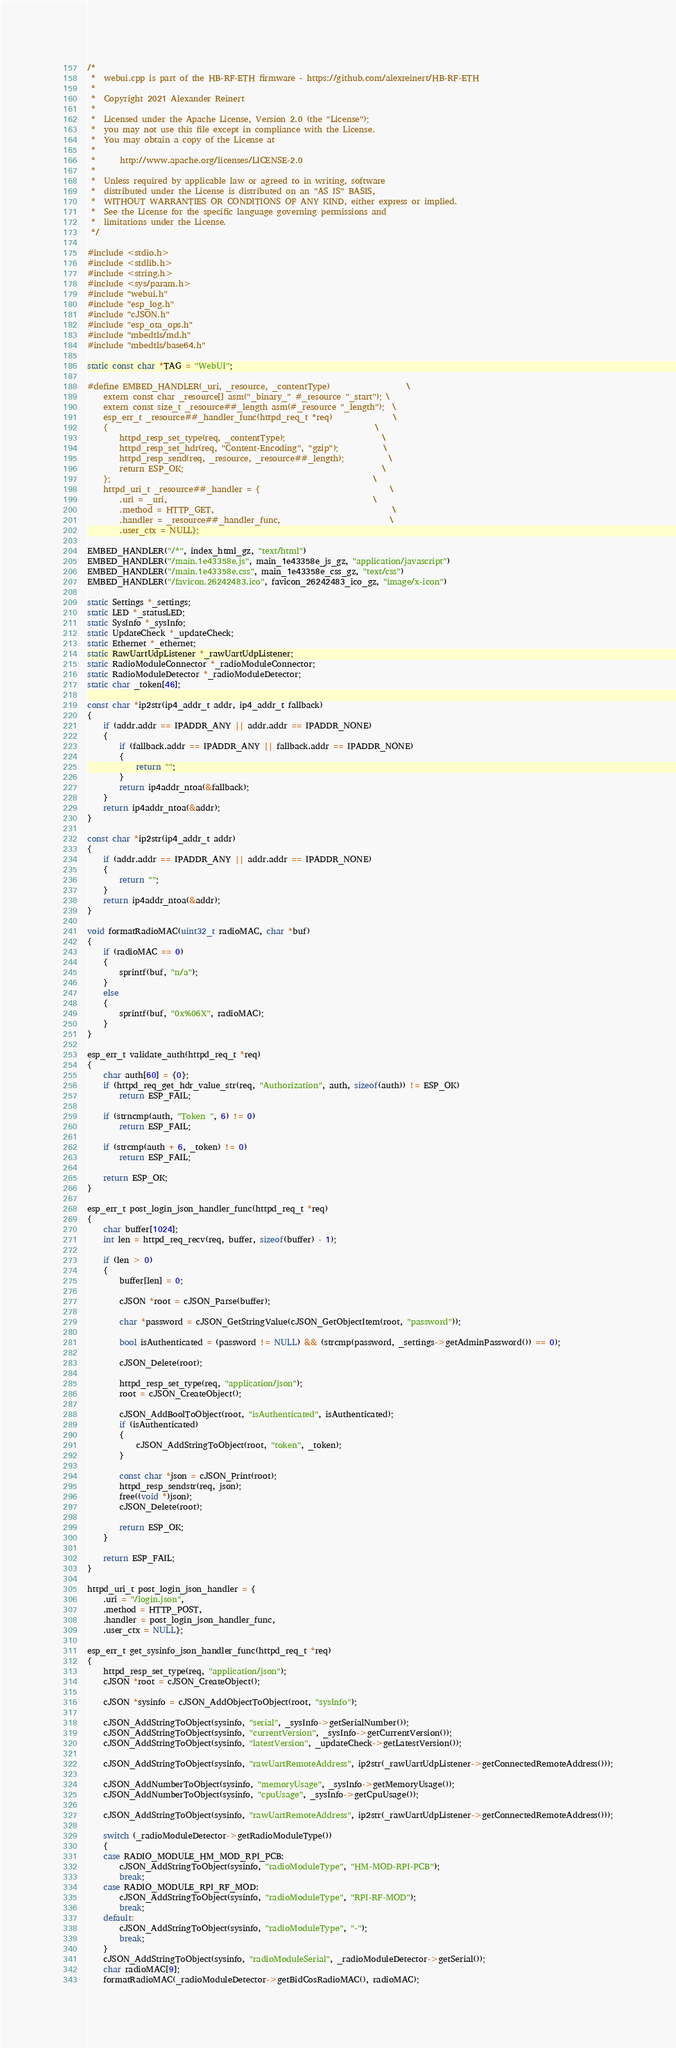Convert code to text. <code><loc_0><loc_0><loc_500><loc_500><_C++_>/* 
 *  webui.cpp is part of the HB-RF-ETH firmware - https://github.com/alexreinert/HB-RF-ETH
 *  
 *  Copyright 2021 Alexander Reinert
 *  
 *  Licensed under the Apache License, Version 2.0 (the "License");
 *  you may not use this file except in compliance with the License.
 *  You may obtain a copy of the License at
 *  
 *      http://www.apache.org/licenses/LICENSE-2.0
 *  
 *  Unless required by applicable law or agreed to in writing, software
 *  distributed under the License is distributed on an "AS IS" BASIS,
 *  WITHOUT WARRANTIES OR CONDITIONS OF ANY KIND, either express or implied.
 *  See the License for the specific language governing permissions and
 *  limitations under the License.
 */

#include <stdio.h>
#include <stdlib.h>
#include <string.h>
#include <sys/param.h>
#include "webui.h"
#include "esp_log.h"
#include "cJSON.h"
#include "esp_ota_ops.h"
#include "mbedtls/md.h"
#include "mbedtls/base64.h"

static const char *TAG = "WebUI";

#define EMBED_HANDLER(_uri, _resource, _contentType)                   \
    extern const char _resource[] asm("_binary_" #_resource "_start"); \
    extern const size_t _resource##_length asm(#_resource "_length");  \
    esp_err_t _resource##_handler_func(httpd_req_t *req)               \
    {                                                                  \
        httpd_resp_set_type(req, _contentType);                        \
        httpd_resp_set_hdr(req, "Content-Encoding", "gzip");           \
        httpd_resp_send(req, _resource, _resource##_length);           \
        return ESP_OK;                                                 \
    };                                                                 \
    httpd_uri_t _resource##_handler = {                                \
        .uri = _uri,                                                   \
        .method = HTTP_GET,                                            \
        .handler = _resource##_handler_func,                           \
        .user_ctx = NULL};

EMBED_HANDLER("/*", index_html_gz, "text/html")
EMBED_HANDLER("/main.1e43358e.js", main_1e43358e_js_gz, "application/javascript")
EMBED_HANDLER("/main.1e43358e.css", main_1e43358e_css_gz, "text/css")
EMBED_HANDLER("/favicon.26242483.ico", favicon_26242483_ico_gz, "image/x-icon")

static Settings *_settings;
static LED *_statusLED;
static SysInfo *_sysInfo;
static UpdateCheck *_updateCheck;
static Ethernet *_ethernet;
static RawUartUdpListener *_rawUartUdpListener;
static RadioModuleConnector *_radioModuleConnector;
static RadioModuleDetector *_radioModuleDetector;
static char _token[46];

const char *ip2str(ip4_addr_t addr, ip4_addr_t fallback)
{
    if (addr.addr == IPADDR_ANY || addr.addr == IPADDR_NONE)
    {
        if (fallback.addr == IPADDR_ANY || fallback.addr == IPADDR_NONE)
        {
            return "";
        }
        return ip4addr_ntoa(&fallback);
    }
    return ip4addr_ntoa(&addr);
}

const char *ip2str(ip4_addr_t addr)
{
    if (addr.addr == IPADDR_ANY || addr.addr == IPADDR_NONE)
    {
        return "";
    }
    return ip4addr_ntoa(&addr);
}

void formatRadioMAC(uint32_t radioMAC, char *buf)
{
    if (radioMAC == 0)
    {
        sprintf(buf, "n/a");
    }
    else
    {
        sprintf(buf, "0x%06X", radioMAC);
    }
}

esp_err_t validate_auth(httpd_req_t *req)
{
    char auth[60] = {0};
    if (httpd_req_get_hdr_value_str(req, "Authorization", auth, sizeof(auth)) != ESP_OK)
        return ESP_FAIL;

    if (strncmp(auth, "Token ", 6) != 0)
        return ESP_FAIL;

    if (strcmp(auth + 6, _token) != 0)
        return ESP_FAIL;

    return ESP_OK;
}

esp_err_t post_login_json_handler_func(httpd_req_t *req)
{
    char buffer[1024];
    int len = httpd_req_recv(req, buffer, sizeof(buffer) - 1);

    if (len > 0)
    {
        buffer[len] = 0;

        cJSON *root = cJSON_Parse(buffer);

        char *password = cJSON_GetStringValue(cJSON_GetObjectItem(root, "password"));

        bool isAuthenticated = (password != NULL) && (strcmp(password, _settings->getAdminPassword()) == 0);

        cJSON_Delete(root);

        httpd_resp_set_type(req, "application/json");
        root = cJSON_CreateObject();

        cJSON_AddBoolToObject(root, "isAuthenticated", isAuthenticated);
        if (isAuthenticated)
        {
            cJSON_AddStringToObject(root, "token", _token);
        }

        const char *json = cJSON_Print(root);
        httpd_resp_sendstr(req, json);
        free((void *)json);
        cJSON_Delete(root);

        return ESP_OK;
    }

    return ESP_FAIL;
}

httpd_uri_t post_login_json_handler = {
    .uri = "/login.json",
    .method = HTTP_POST,
    .handler = post_login_json_handler_func,
    .user_ctx = NULL};

esp_err_t get_sysinfo_json_handler_func(httpd_req_t *req)
{
    httpd_resp_set_type(req, "application/json");
    cJSON *root = cJSON_CreateObject();

    cJSON *sysinfo = cJSON_AddObjectToObject(root, "sysInfo");

    cJSON_AddStringToObject(sysinfo, "serial", _sysInfo->getSerialNumber());
    cJSON_AddStringToObject(sysinfo, "currentVersion", _sysInfo->getCurrentVersion());
    cJSON_AddStringToObject(sysinfo, "latestVersion", _updateCheck->getLatestVersion());

    cJSON_AddStringToObject(sysinfo, "rawUartRemoteAddress", ip2str(_rawUartUdpListener->getConnectedRemoteAddress()));

    cJSON_AddNumberToObject(sysinfo, "memoryUsage", _sysInfo->getMemoryUsage());
    cJSON_AddNumberToObject(sysinfo, "cpuUsage", _sysInfo->getCpuUsage());

    cJSON_AddStringToObject(sysinfo, "rawUartRemoteAddress", ip2str(_rawUartUdpListener->getConnectedRemoteAddress()));

    switch (_radioModuleDetector->getRadioModuleType())
    {
    case RADIO_MODULE_HM_MOD_RPI_PCB:
        cJSON_AddStringToObject(sysinfo, "radioModuleType", "HM-MOD-RPI-PCB");
        break;
    case RADIO_MODULE_RPI_RF_MOD:
        cJSON_AddStringToObject(sysinfo, "radioModuleType", "RPI-RF-MOD");
        break;
    default:
        cJSON_AddStringToObject(sysinfo, "radioModuleType", "-");
        break;
    }
    cJSON_AddStringToObject(sysinfo, "radioModuleSerial", _radioModuleDetector->getSerial());
    char radioMAC[9];
    formatRadioMAC(_radioModuleDetector->getBidCosRadioMAC(), radioMAC);</code> 